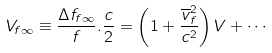Convert formula to latex. <formula><loc_0><loc_0><loc_500><loc_500>V _ { f \infty } \equiv \frac { \Delta f _ { f \infty } } { f } . \frac { c } { 2 } = \left ( 1 + \frac { \overline { v } _ { f } ^ { 2 } } { c ^ { 2 } } \right ) V + \cdots</formula> 